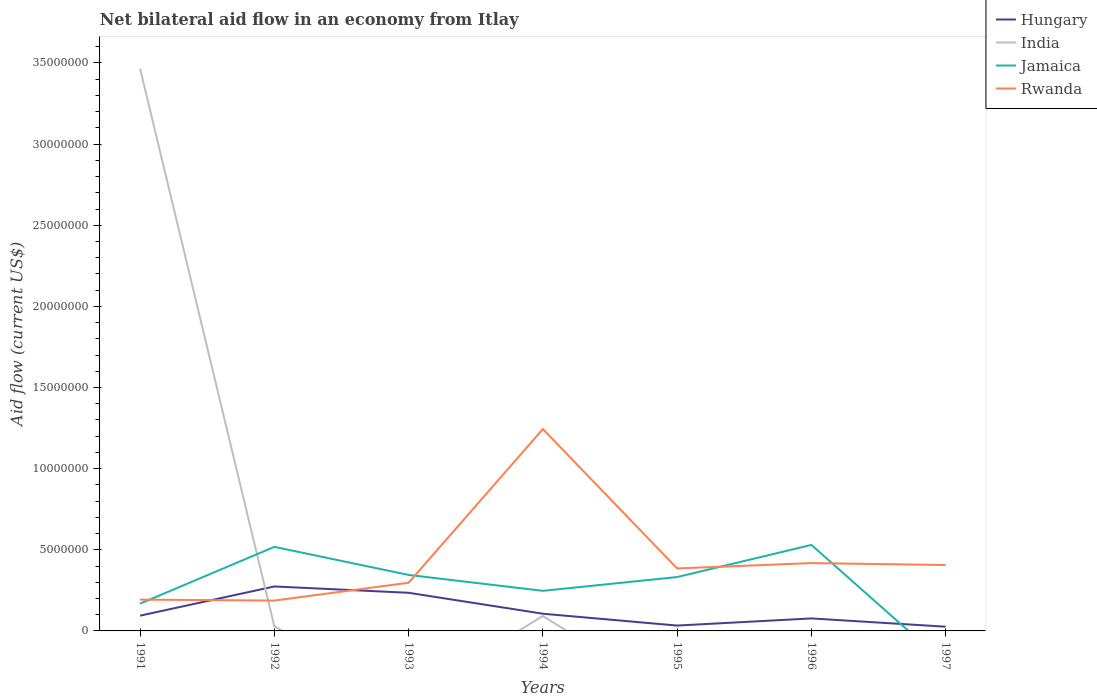How many different coloured lines are there?
Offer a terse response. 4. Is the number of lines equal to the number of legend labels?
Your response must be concise. No. Across all years, what is the maximum net bilateral aid flow in India?
Give a very brief answer. 0. What is the total net bilateral aid flow in India in the graph?
Your answer should be compact. 3.37e+07. What is the difference between the highest and the second highest net bilateral aid flow in Hungary?
Provide a succinct answer. 2.48e+06. Is the net bilateral aid flow in Jamaica strictly greater than the net bilateral aid flow in India over the years?
Give a very brief answer. No. What is the difference between two consecutive major ticks on the Y-axis?
Offer a very short reply. 5.00e+06. Are the values on the major ticks of Y-axis written in scientific E-notation?
Offer a very short reply. No. Where does the legend appear in the graph?
Give a very brief answer. Top right. What is the title of the graph?
Your response must be concise. Net bilateral aid flow in an economy from Itlay. Does "India" appear as one of the legend labels in the graph?
Your answer should be very brief. Yes. What is the Aid flow (current US$) of Hungary in 1991?
Give a very brief answer. 9.40e+05. What is the Aid flow (current US$) of India in 1991?
Give a very brief answer. 3.46e+07. What is the Aid flow (current US$) of Jamaica in 1991?
Keep it short and to the point. 1.68e+06. What is the Aid flow (current US$) in Rwanda in 1991?
Provide a short and direct response. 1.93e+06. What is the Aid flow (current US$) of Hungary in 1992?
Ensure brevity in your answer.  2.74e+06. What is the Aid flow (current US$) in Jamaica in 1992?
Ensure brevity in your answer.  5.18e+06. What is the Aid flow (current US$) of Rwanda in 1992?
Your answer should be compact. 1.87e+06. What is the Aid flow (current US$) of Hungary in 1993?
Your response must be concise. 2.35e+06. What is the Aid flow (current US$) of Jamaica in 1993?
Give a very brief answer. 3.45e+06. What is the Aid flow (current US$) in Rwanda in 1993?
Your answer should be compact. 2.97e+06. What is the Aid flow (current US$) of Hungary in 1994?
Offer a terse response. 1.06e+06. What is the Aid flow (current US$) in India in 1994?
Your answer should be very brief. 9.20e+05. What is the Aid flow (current US$) in Jamaica in 1994?
Make the answer very short. 2.47e+06. What is the Aid flow (current US$) in Rwanda in 1994?
Ensure brevity in your answer.  1.24e+07. What is the Aid flow (current US$) of Hungary in 1995?
Offer a terse response. 3.30e+05. What is the Aid flow (current US$) in India in 1995?
Provide a succinct answer. 0. What is the Aid flow (current US$) in Jamaica in 1995?
Provide a succinct answer. 3.32e+06. What is the Aid flow (current US$) in Rwanda in 1995?
Your answer should be compact. 3.85e+06. What is the Aid flow (current US$) in Hungary in 1996?
Ensure brevity in your answer.  7.70e+05. What is the Aid flow (current US$) in Jamaica in 1996?
Offer a terse response. 5.30e+06. What is the Aid flow (current US$) of Rwanda in 1996?
Ensure brevity in your answer.  4.18e+06. What is the Aid flow (current US$) in India in 1997?
Make the answer very short. 0. What is the Aid flow (current US$) in Jamaica in 1997?
Offer a terse response. 0. What is the Aid flow (current US$) of Rwanda in 1997?
Your response must be concise. 4.06e+06. Across all years, what is the maximum Aid flow (current US$) in Hungary?
Provide a succinct answer. 2.74e+06. Across all years, what is the maximum Aid flow (current US$) of India?
Make the answer very short. 3.46e+07. Across all years, what is the maximum Aid flow (current US$) of Jamaica?
Offer a terse response. 5.30e+06. Across all years, what is the maximum Aid flow (current US$) in Rwanda?
Offer a terse response. 1.24e+07. Across all years, what is the minimum Aid flow (current US$) in Hungary?
Make the answer very short. 2.60e+05. Across all years, what is the minimum Aid flow (current US$) of Rwanda?
Offer a terse response. 1.87e+06. What is the total Aid flow (current US$) in Hungary in the graph?
Your answer should be compact. 8.45e+06. What is the total Aid flow (current US$) of India in the graph?
Your response must be concise. 3.58e+07. What is the total Aid flow (current US$) of Jamaica in the graph?
Provide a short and direct response. 2.14e+07. What is the total Aid flow (current US$) of Rwanda in the graph?
Ensure brevity in your answer.  3.13e+07. What is the difference between the Aid flow (current US$) of Hungary in 1991 and that in 1992?
Provide a succinct answer. -1.80e+06. What is the difference between the Aid flow (current US$) in India in 1991 and that in 1992?
Offer a very short reply. 3.44e+07. What is the difference between the Aid flow (current US$) in Jamaica in 1991 and that in 1992?
Your answer should be compact. -3.50e+06. What is the difference between the Aid flow (current US$) of Rwanda in 1991 and that in 1992?
Ensure brevity in your answer.  6.00e+04. What is the difference between the Aid flow (current US$) of Hungary in 1991 and that in 1993?
Your response must be concise. -1.41e+06. What is the difference between the Aid flow (current US$) in Jamaica in 1991 and that in 1993?
Give a very brief answer. -1.77e+06. What is the difference between the Aid flow (current US$) of Rwanda in 1991 and that in 1993?
Give a very brief answer. -1.04e+06. What is the difference between the Aid flow (current US$) in Hungary in 1991 and that in 1994?
Give a very brief answer. -1.20e+05. What is the difference between the Aid flow (current US$) of India in 1991 and that in 1994?
Provide a short and direct response. 3.37e+07. What is the difference between the Aid flow (current US$) of Jamaica in 1991 and that in 1994?
Give a very brief answer. -7.90e+05. What is the difference between the Aid flow (current US$) of Rwanda in 1991 and that in 1994?
Your answer should be compact. -1.05e+07. What is the difference between the Aid flow (current US$) of Hungary in 1991 and that in 1995?
Your response must be concise. 6.10e+05. What is the difference between the Aid flow (current US$) in Jamaica in 1991 and that in 1995?
Provide a succinct answer. -1.64e+06. What is the difference between the Aid flow (current US$) of Rwanda in 1991 and that in 1995?
Your response must be concise. -1.92e+06. What is the difference between the Aid flow (current US$) of Hungary in 1991 and that in 1996?
Give a very brief answer. 1.70e+05. What is the difference between the Aid flow (current US$) of Jamaica in 1991 and that in 1996?
Provide a short and direct response. -3.62e+06. What is the difference between the Aid flow (current US$) in Rwanda in 1991 and that in 1996?
Ensure brevity in your answer.  -2.25e+06. What is the difference between the Aid flow (current US$) in Hungary in 1991 and that in 1997?
Keep it short and to the point. 6.80e+05. What is the difference between the Aid flow (current US$) of Rwanda in 1991 and that in 1997?
Make the answer very short. -2.13e+06. What is the difference between the Aid flow (current US$) in Jamaica in 1992 and that in 1993?
Your response must be concise. 1.73e+06. What is the difference between the Aid flow (current US$) of Rwanda in 1992 and that in 1993?
Your answer should be very brief. -1.10e+06. What is the difference between the Aid flow (current US$) in Hungary in 1992 and that in 1994?
Your answer should be very brief. 1.68e+06. What is the difference between the Aid flow (current US$) in India in 1992 and that in 1994?
Your answer should be very brief. -6.40e+05. What is the difference between the Aid flow (current US$) of Jamaica in 1992 and that in 1994?
Offer a terse response. 2.71e+06. What is the difference between the Aid flow (current US$) in Rwanda in 1992 and that in 1994?
Your answer should be very brief. -1.06e+07. What is the difference between the Aid flow (current US$) of Hungary in 1992 and that in 1995?
Provide a succinct answer. 2.41e+06. What is the difference between the Aid flow (current US$) in Jamaica in 1992 and that in 1995?
Give a very brief answer. 1.86e+06. What is the difference between the Aid flow (current US$) of Rwanda in 1992 and that in 1995?
Make the answer very short. -1.98e+06. What is the difference between the Aid flow (current US$) in Hungary in 1992 and that in 1996?
Your response must be concise. 1.97e+06. What is the difference between the Aid flow (current US$) of Rwanda in 1992 and that in 1996?
Offer a very short reply. -2.31e+06. What is the difference between the Aid flow (current US$) of Hungary in 1992 and that in 1997?
Your answer should be very brief. 2.48e+06. What is the difference between the Aid flow (current US$) in Rwanda in 1992 and that in 1997?
Your answer should be very brief. -2.19e+06. What is the difference between the Aid flow (current US$) in Hungary in 1993 and that in 1994?
Make the answer very short. 1.29e+06. What is the difference between the Aid flow (current US$) of Jamaica in 1993 and that in 1994?
Make the answer very short. 9.80e+05. What is the difference between the Aid flow (current US$) in Rwanda in 1993 and that in 1994?
Your answer should be compact. -9.47e+06. What is the difference between the Aid flow (current US$) of Hungary in 1993 and that in 1995?
Offer a terse response. 2.02e+06. What is the difference between the Aid flow (current US$) of Rwanda in 1993 and that in 1995?
Your response must be concise. -8.80e+05. What is the difference between the Aid flow (current US$) of Hungary in 1993 and that in 1996?
Ensure brevity in your answer.  1.58e+06. What is the difference between the Aid flow (current US$) in Jamaica in 1993 and that in 1996?
Offer a terse response. -1.85e+06. What is the difference between the Aid flow (current US$) of Rwanda in 1993 and that in 1996?
Provide a succinct answer. -1.21e+06. What is the difference between the Aid flow (current US$) of Hungary in 1993 and that in 1997?
Your answer should be very brief. 2.09e+06. What is the difference between the Aid flow (current US$) of Rwanda in 1993 and that in 1997?
Provide a succinct answer. -1.09e+06. What is the difference between the Aid flow (current US$) of Hungary in 1994 and that in 1995?
Offer a very short reply. 7.30e+05. What is the difference between the Aid flow (current US$) of Jamaica in 1994 and that in 1995?
Your answer should be very brief. -8.50e+05. What is the difference between the Aid flow (current US$) in Rwanda in 1994 and that in 1995?
Your answer should be very brief. 8.59e+06. What is the difference between the Aid flow (current US$) of Hungary in 1994 and that in 1996?
Your response must be concise. 2.90e+05. What is the difference between the Aid flow (current US$) of Jamaica in 1994 and that in 1996?
Keep it short and to the point. -2.83e+06. What is the difference between the Aid flow (current US$) of Rwanda in 1994 and that in 1996?
Make the answer very short. 8.26e+06. What is the difference between the Aid flow (current US$) of Hungary in 1994 and that in 1997?
Your response must be concise. 8.00e+05. What is the difference between the Aid flow (current US$) in Rwanda in 1994 and that in 1997?
Provide a short and direct response. 8.38e+06. What is the difference between the Aid flow (current US$) of Hungary in 1995 and that in 1996?
Offer a terse response. -4.40e+05. What is the difference between the Aid flow (current US$) of Jamaica in 1995 and that in 1996?
Offer a terse response. -1.98e+06. What is the difference between the Aid flow (current US$) in Rwanda in 1995 and that in 1996?
Keep it short and to the point. -3.30e+05. What is the difference between the Aid flow (current US$) in Hungary in 1995 and that in 1997?
Your response must be concise. 7.00e+04. What is the difference between the Aid flow (current US$) of Hungary in 1996 and that in 1997?
Your answer should be very brief. 5.10e+05. What is the difference between the Aid flow (current US$) of Rwanda in 1996 and that in 1997?
Give a very brief answer. 1.20e+05. What is the difference between the Aid flow (current US$) of Hungary in 1991 and the Aid flow (current US$) of India in 1992?
Offer a terse response. 6.60e+05. What is the difference between the Aid flow (current US$) in Hungary in 1991 and the Aid flow (current US$) in Jamaica in 1992?
Provide a succinct answer. -4.24e+06. What is the difference between the Aid flow (current US$) in Hungary in 1991 and the Aid flow (current US$) in Rwanda in 1992?
Offer a very short reply. -9.30e+05. What is the difference between the Aid flow (current US$) of India in 1991 and the Aid flow (current US$) of Jamaica in 1992?
Offer a terse response. 2.95e+07. What is the difference between the Aid flow (current US$) of India in 1991 and the Aid flow (current US$) of Rwanda in 1992?
Your response must be concise. 3.28e+07. What is the difference between the Aid flow (current US$) of Hungary in 1991 and the Aid flow (current US$) of Jamaica in 1993?
Offer a terse response. -2.51e+06. What is the difference between the Aid flow (current US$) of Hungary in 1991 and the Aid flow (current US$) of Rwanda in 1993?
Make the answer very short. -2.03e+06. What is the difference between the Aid flow (current US$) in India in 1991 and the Aid flow (current US$) in Jamaica in 1993?
Provide a succinct answer. 3.12e+07. What is the difference between the Aid flow (current US$) of India in 1991 and the Aid flow (current US$) of Rwanda in 1993?
Give a very brief answer. 3.17e+07. What is the difference between the Aid flow (current US$) of Jamaica in 1991 and the Aid flow (current US$) of Rwanda in 1993?
Offer a very short reply. -1.29e+06. What is the difference between the Aid flow (current US$) in Hungary in 1991 and the Aid flow (current US$) in Jamaica in 1994?
Provide a short and direct response. -1.53e+06. What is the difference between the Aid flow (current US$) of Hungary in 1991 and the Aid flow (current US$) of Rwanda in 1994?
Your answer should be very brief. -1.15e+07. What is the difference between the Aid flow (current US$) of India in 1991 and the Aid flow (current US$) of Jamaica in 1994?
Provide a succinct answer. 3.22e+07. What is the difference between the Aid flow (current US$) in India in 1991 and the Aid flow (current US$) in Rwanda in 1994?
Give a very brief answer. 2.22e+07. What is the difference between the Aid flow (current US$) in Jamaica in 1991 and the Aid flow (current US$) in Rwanda in 1994?
Make the answer very short. -1.08e+07. What is the difference between the Aid flow (current US$) of Hungary in 1991 and the Aid flow (current US$) of Jamaica in 1995?
Provide a short and direct response. -2.38e+06. What is the difference between the Aid flow (current US$) of Hungary in 1991 and the Aid flow (current US$) of Rwanda in 1995?
Your answer should be compact. -2.91e+06. What is the difference between the Aid flow (current US$) of India in 1991 and the Aid flow (current US$) of Jamaica in 1995?
Give a very brief answer. 3.13e+07. What is the difference between the Aid flow (current US$) in India in 1991 and the Aid flow (current US$) in Rwanda in 1995?
Provide a succinct answer. 3.08e+07. What is the difference between the Aid flow (current US$) of Jamaica in 1991 and the Aid flow (current US$) of Rwanda in 1995?
Provide a short and direct response. -2.17e+06. What is the difference between the Aid flow (current US$) in Hungary in 1991 and the Aid flow (current US$) in Jamaica in 1996?
Give a very brief answer. -4.36e+06. What is the difference between the Aid flow (current US$) of Hungary in 1991 and the Aid flow (current US$) of Rwanda in 1996?
Your response must be concise. -3.24e+06. What is the difference between the Aid flow (current US$) in India in 1991 and the Aid flow (current US$) in Jamaica in 1996?
Offer a very short reply. 2.94e+07. What is the difference between the Aid flow (current US$) in India in 1991 and the Aid flow (current US$) in Rwanda in 1996?
Your answer should be compact. 3.05e+07. What is the difference between the Aid flow (current US$) of Jamaica in 1991 and the Aid flow (current US$) of Rwanda in 1996?
Make the answer very short. -2.50e+06. What is the difference between the Aid flow (current US$) of Hungary in 1991 and the Aid flow (current US$) of Rwanda in 1997?
Keep it short and to the point. -3.12e+06. What is the difference between the Aid flow (current US$) of India in 1991 and the Aid flow (current US$) of Rwanda in 1997?
Provide a succinct answer. 3.06e+07. What is the difference between the Aid flow (current US$) in Jamaica in 1991 and the Aid flow (current US$) in Rwanda in 1997?
Your answer should be compact. -2.38e+06. What is the difference between the Aid flow (current US$) of Hungary in 1992 and the Aid flow (current US$) of Jamaica in 1993?
Ensure brevity in your answer.  -7.10e+05. What is the difference between the Aid flow (current US$) in India in 1992 and the Aid flow (current US$) in Jamaica in 1993?
Provide a short and direct response. -3.17e+06. What is the difference between the Aid flow (current US$) in India in 1992 and the Aid flow (current US$) in Rwanda in 1993?
Make the answer very short. -2.69e+06. What is the difference between the Aid flow (current US$) in Jamaica in 1992 and the Aid flow (current US$) in Rwanda in 1993?
Your response must be concise. 2.21e+06. What is the difference between the Aid flow (current US$) in Hungary in 1992 and the Aid flow (current US$) in India in 1994?
Provide a short and direct response. 1.82e+06. What is the difference between the Aid flow (current US$) of Hungary in 1992 and the Aid flow (current US$) of Rwanda in 1994?
Give a very brief answer. -9.70e+06. What is the difference between the Aid flow (current US$) of India in 1992 and the Aid flow (current US$) of Jamaica in 1994?
Make the answer very short. -2.19e+06. What is the difference between the Aid flow (current US$) of India in 1992 and the Aid flow (current US$) of Rwanda in 1994?
Give a very brief answer. -1.22e+07. What is the difference between the Aid flow (current US$) of Jamaica in 1992 and the Aid flow (current US$) of Rwanda in 1994?
Your answer should be very brief. -7.26e+06. What is the difference between the Aid flow (current US$) in Hungary in 1992 and the Aid flow (current US$) in Jamaica in 1995?
Keep it short and to the point. -5.80e+05. What is the difference between the Aid flow (current US$) of Hungary in 1992 and the Aid flow (current US$) of Rwanda in 1995?
Offer a very short reply. -1.11e+06. What is the difference between the Aid flow (current US$) in India in 1992 and the Aid flow (current US$) in Jamaica in 1995?
Ensure brevity in your answer.  -3.04e+06. What is the difference between the Aid flow (current US$) of India in 1992 and the Aid flow (current US$) of Rwanda in 1995?
Provide a short and direct response. -3.57e+06. What is the difference between the Aid flow (current US$) of Jamaica in 1992 and the Aid flow (current US$) of Rwanda in 1995?
Your response must be concise. 1.33e+06. What is the difference between the Aid flow (current US$) in Hungary in 1992 and the Aid flow (current US$) in Jamaica in 1996?
Give a very brief answer. -2.56e+06. What is the difference between the Aid flow (current US$) in Hungary in 1992 and the Aid flow (current US$) in Rwanda in 1996?
Offer a very short reply. -1.44e+06. What is the difference between the Aid flow (current US$) in India in 1992 and the Aid flow (current US$) in Jamaica in 1996?
Provide a short and direct response. -5.02e+06. What is the difference between the Aid flow (current US$) of India in 1992 and the Aid flow (current US$) of Rwanda in 1996?
Your response must be concise. -3.90e+06. What is the difference between the Aid flow (current US$) in Jamaica in 1992 and the Aid flow (current US$) in Rwanda in 1996?
Provide a short and direct response. 1.00e+06. What is the difference between the Aid flow (current US$) in Hungary in 1992 and the Aid flow (current US$) in Rwanda in 1997?
Offer a terse response. -1.32e+06. What is the difference between the Aid flow (current US$) of India in 1992 and the Aid flow (current US$) of Rwanda in 1997?
Offer a very short reply. -3.78e+06. What is the difference between the Aid flow (current US$) of Jamaica in 1992 and the Aid flow (current US$) of Rwanda in 1997?
Offer a terse response. 1.12e+06. What is the difference between the Aid flow (current US$) of Hungary in 1993 and the Aid flow (current US$) of India in 1994?
Your response must be concise. 1.43e+06. What is the difference between the Aid flow (current US$) of Hungary in 1993 and the Aid flow (current US$) of Rwanda in 1994?
Offer a terse response. -1.01e+07. What is the difference between the Aid flow (current US$) of Jamaica in 1993 and the Aid flow (current US$) of Rwanda in 1994?
Give a very brief answer. -8.99e+06. What is the difference between the Aid flow (current US$) of Hungary in 1993 and the Aid flow (current US$) of Jamaica in 1995?
Give a very brief answer. -9.70e+05. What is the difference between the Aid flow (current US$) of Hungary in 1993 and the Aid flow (current US$) of Rwanda in 1995?
Ensure brevity in your answer.  -1.50e+06. What is the difference between the Aid flow (current US$) of Jamaica in 1993 and the Aid flow (current US$) of Rwanda in 1995?
Provide a succinct answer. -4.00e+05. What is the difference between the Aid flow (current US$) of Hungary in 1993 and the Aid flow (current US$) of Jamaica in 1996?
Your response must be concise. -2.95e+06. What is the difference between the Aid flow (current US$) of Hungary in 1993 and the Aid flow (current US$) of Rwanda in 1996?
Give a very brief answer. -1.83e+06. What is the difference between the Aid flow (current US$) in Jamaica in 1993 and the Aid flow (current US$) in Rwanda in 1996?
Your answer should be compact. -7.30e+05. What is the difference between the Aid flow (current US$) of Hungary in 1993 and the Aid flow (current US$) of Rwanda in 1997?
Give a very brief answer. -1.71e+06. What is the difference between the Aid flow (current US$) in Jamaica in 1993 and the Aid flow (current US$) in Rwanda in 1997?
Your response must be concise. -6.10e+05. What is the difference between the Aid flow (current US$) of Hungary in 1994 and the Aid flow (current US$) of Jamaica in 1995?
Your response must be concise. -2.26e+06. What is the difference between the Aid flow (current US$) of Hungary in 1994 and the Aid flow (current US$) of Rwanda in 1995?
Your response must be concise. -2.79e+06. What is the difference between the Aid flow (current US$) in India in 1994 and the Aid flow (current US$) in Jamaica in 1995?
Give a very brief answer. -2.40e+06. What is the difference between the Aid flow (current US$) of India in 1994 and the Aid flow (current US$) of Rwanda in 1995?
Make the answer very short. -2.93e+06. What is the difference between the Aid flow (current US$) of Jamaica in 1994 and the Aid flow (current US$) of Rwanda in 1995?
Offer a terse response. -1.38e+06. What is the difference between the Aid flow (current US$) of Hungary in 1994 and the Aid flow (current US$) of Jamaica in 1996?
Offer a very short reply. -4.24e+06. What is the difference between the Aid flow (current US$) in Hungary in 1994 and the Aid flow (current US$) in Rwanda in 1996?
Give a very brief answer. -3.12e+06. What is the difference between the Aid flow (current US$) in India in 1994 and the Aid flow (current US$) in Jamaica in 1996?
Provide a succinct answer. -4.38e+06. What is the difference between the Aid flow (current US$) in India in 1994 and the Aid flow (current US$) in Rwanda in 1996?
Your response must be concise. -3.26e+06. What is the difference between the Aid flow (current US$) in Jamaica in 1994 and the Aid flow (current US$) in Rwanda in 1996?
Provide a short and direct response. -1.71e+06. What is the difference between the Aid flow (current US$) of Hungary in 1994 and the Aid flow (current US$) of Rwanda in 1997?
Give a very brief answer. -3.00e+06. What is the difference between the Aid flow (current US$) of India in 1994 and the Aid flow (current US$) of Rwanda in 1997?
Your answer should be very brief. -3.14e+06. What is the difference between the Aid flow (current US$) of Jamaica in 1994 and the Aid flow (current US$) of Rwanda in 1997?
Ensure brevity in your answer.  -1.59e+06. What is the difference between the Aid flow (current US$) of Hungary in 1995 and the Aid flow (current US$) of Jamaica in 1996?
Offer a very short reply. -4.97e+06. What is the difference between the Aid flow (current US$) in Hungary in 1995 and the Aid flow (current US$) in Rwanda in 1996?
Make the answer very short. -3.85e+06. What is the difference between the Aid flow (current US$) of Jamaica in 1995 and the Aid flow (current US$) of Rwanda in 1996?
Provide a succinct answer. -8.60e+05. What is the difference between the Aid flow (current US$) of Hungary in 1995 and the Aid flow (current US$) of Rwanda in 1997?
Offer a terse response. -3.73e+06. What is the difference between the Aid flow (current US$) in Jamaica in 1995 and the Aid flow (current US$) in Rwanda in 1997?
Give a very brief answer. -7.40e+05. What is the difference between the Aid flow (current US$) in Hungary in 1996 and the Aid flow (current US$) in Rwanda in 1997?
Make the answer very short. -3.29e+06. What is the difference between the Aid flow (current US$) in Jamaica in 1996 and the Aid flow (current US$) in Rwanda in 1997?
Give a very brief answer. 1.24e+06. What is the average Aid flow (current US$) of Hungary per year?
Ensure brevity in your answer.  1.21e+06. What is the average Aid flow (current US$) in India per year?
Provide a succinct answer. 5.12e+06. What is the average Aid flow (current US$) in Jamaica per year?
Your response must be concise. 3.06e+06. What is the average Aid flow (current US$) of Rwanda per year?
Your answer should be compact. 4.47e+06. In the year 1991, what is the difference between the Aid flow (current US$) of Hungary and Aid flow (current US$) of India?
Ensure brevity in your answer.  -3.37e+07. In the year 1991, what is the difference between the Aid flow (current US$) of Hungary and Aid flow (current US$) of Jamaica?
Ensure brevity in your answer.  -7.40e+05. In the year 1991, what is the difference between the Aid flow (current US$) of Hungary and Aid flow (current US$) of Rwanda?
Provide a short and direct response. -9.90e+05. In the year 1991, what is the difference between the Aid flow (current US$) in India and Aid flow (current US$) in Jamaica?
Provide a short and direct response. 3.30e+07. In the year 1991, what is the difference between the Aid flow (current US$) in India and Aid flow (current US$) in Rwanda?
Provide a short and direct response. 3.27e+07. In the year 1992, what is the difference between the Aid flow (current US$) in Hungary and Aid flow (current US$) in India?
Your response must be concise. 2.46e+06. In the year 1992, what is the difference between the Aid flow (current US$) in Hungary and Aid flow (current US$) in Jamaica?
Your response must be concise. -2.44e+06. In the year 1992, what is the difference between the Aid flow (current US$) in Hungary and Aid flow (current US$) in Rwanda?
Provide a succinct answer. 8.70e+05. In the year 1992, what is the difference between the Aid flow (current US$) of India and Aid flow (current US$) of Jamaica?
Your response must be concise. -4.90e+06. In the year 1992, what is the difference between the Aid flow (current US$) of India and Aid flow (current US$) of Rwanda?
Your response must be concise. -1.59e+06. In the year 1992, what is the difference between the Aid flow (current US$) in Jamaica and Aid flow (current US$) in Rwanda?
Offer a terse response. 3.31e+06. In the year 1993, what is the difference between the Aid flow (current US$) in Hungary and Aid flow (current US$) in Jamaica?
Offer a terse response. -1.10e+06. In the year 1993, what is the difference between the Aid flow (current US$) of Hungary and Aid flow (current US$) of Rwanda?
Give a very brief answer. -6.20e+05. In the year 1994, what is the difference between the Aid flow (current US$) in Hungary and Aid flow (current US$) in Jamaica?
Provide a short and direct response. -1.41e+06. In the year 1994, what is the difference between the Aid flow (current US$) in Hungary and Aid flow (current US$) in Rwanda?
Your answer should be very brief. -1.14e+07. In the year 1994, what is the difference between the Aid flow (current US$) of India and Aid flow (current US$) of Jamaica?
Your answer should be very brief. -1.55e+06. In the year 1994, what is the difference between the Aid flow (current US$) of India and Aid flow (current US$) of Rwanda?
Offer a terse response. -1.15e+07. In the year 1994, what is the difference between the Aid flow (current US$) in Jamaica and Aid flow (current US$) in Rwanda?
Keep it short and to the point. -9.97e+06. In the year 1995, what is the difference between the Aid flow (current US$) in Hungary and Aid flow (current US$) in Jamaica?
Give a very brief answer. -2.99e+06. In the year 1995, what is the difference between the Aid flow (current US$) in Hungary and Aid flow (current US$) in Rwanda?
Give a very brief answer. -3.52e+06. In the year 1995, what is the difference between the Aid flow (current US$) of Jamaica and Aid flow (current US$) of Rwanda?
Give a very brief answer. -5.30e+05. In the year 1996, what is the difference between the Aid flow (current US$) in Hungary and Aid flow (current US$) in Jamaica?
Make the answer very short. -4.53e+06. In the year 1996, what is the difference between the Aid flow (current US$) in Hungary and Aid flow (current US$) in Rwanda?
Your answer should be compact. -3.41e+06. In the year 1996, what is the difference between the Aid flow (current US$) of Jamaica and Aid flow (current US$) of Rwanda?
Your answer should be very brief. 1.12e+06. In the year 1997, what is the difference between the Aid flow (current US$) of Hungary and Aid flow (current US$) of Rwanda?
Provide a short and direct response. -3.80e+06. What is the ratio of the Aid flow (current US$) of Hungary in 1991 to that in 1992?
Offer a very short reply. 0.34. What is the ratio of the Aid flow (current US$) of India in 1991 to that in 1992?
Keep it short and to the point. 123.75. What is the ratio of the Aid flow (current US$) of Jamaica in 1991 to that in 1992?
Give a very brief answer. 0.32. What is the ratio of the Aid flow (current US$) of Rwanda in 1991 to that in 1992?
Your answer should be very brief. 1.03. What is the ratio of the Aid flow (current US$) in Jamaica in 1991 to that in 1993?
Ensure brevity in your answer.  0.49. What is the ratio of the Aid flow (current US$) in Rwanda in 1991 to that in 1993?
Your response must be concise. 0.65. What is the ratio of the Aid flow (current US$) in Hungary in 1991 to that in 1994?
Ensure brevity in your answer.  0.89. What is the ratio of the Aid flow (current US$) of India in 1991 to that in 1994?
Keep it short and to the point. 37.66. What is the ratio of the Aid flow (current US$) of Jamaica in 1991 to that in 1994?
Offer a terse response. 0.68. What is the ratio of the Aid flow (current US$) in Rwanda in 1991 to that in 1994?
Your answer should be compact. 0.16. What is the ratio of the Aid flow (current US$) in Hungary in 1991 to that in 1995?
Ensure brevity in your answer.  2.85. What is the ratio of the Aid flow (current US$) in Jamaica in 1991 to that in 1995?
Your answer should be compact. 0.51. What is the ratio of the Aid flow (current US$) in Rwanda in 1991 to that in 1995?
Provide a succinct answer. 0.5. What is the ratio of the Aid flow (current US$) in Hungary in 1991 to that in 1996?
Make the answer very short. 1.22. What is the ratio of the Aid flow (current US$) in Jamaica in 1991 to that in 1996?
Your answer should be very brief. 0.32. What is the ratio of the Aid flow (current US$) in Rwanda in 1991 to that in 1996?
Keep it short and to the point. 0.46. What is the ratio of the Aid flow (current US$) of Hungary in 1991 to that in 1997?
Your answer should be very brief. 3.62. What is the ratio of the Aid flow (current US$) in Rwanda in 1991 to that in 1997?
Your response must be concise. 0.48. What is the ratio of the Aid flow (current US$) in Hungary in 1992 to that in 1993?
Provide a short and direct response. 1.17. What is the ratio of the Aid flow (current US$) in Jamaica in 1992 to that in 1993?
Your answer should be very brief. 1.5. What is the ratio of the Aid flow (current US$) of Rwanda in 1992 to that in 1993?
Your answer should be very brief. 0.63. What is the ratio of the Aid flow (current US$) of Hungary in 1992 to that in 1994?
Provide a succinct answer. 2.58. What is the ratio of the Aid flow (current US$) in India in 1992 to that in 1994?
Give a very brief answer. 0.3. What is the ratio of the Aid flow (current US$) in Jamaica in 1992 to that in 1994?
Your response must be concise. 2.1. What is the ratio of the Aid flow (current US$) of Rwanda in 1992 to that in 1994?
Provide a succinct answer. 0.15. What is the ratio of the Aid flow (current US$) of Hungary in 1992 to that in 1995?
Offer a terse response. 8.3. What is the ratio of the Aid flow (current US$) of Jamaica in 1992 to that in 1995?
Keep it short and to the point. 1.56. What is the ratio of the Aid flow (current US$) in Rwanda in 1992 to that in 1995?
Give a very brief answer. 0.49. What is the ratio of the Aid flow (current US$) in Hungary in 1992 to that in 1996?
Provide a succinct answer. 3.56. What is the ratio of the Aid flow (current US$) in Jamaica in 1992 to that in 1996?
Ensure brevity in your answer.  0.98. What is the ratio of the Aid flow (current US$) of Rwanda in 1992 to that in 1996?
Ensure brevity in your answer.  0.45. What is the ratio of the Aid flow (current US$) of Hungary in 1992 to that in 1997?
Your answer should be very brief. 10.54. What is the ratio of the Aid flow (current US$) of Rwanda in 1992 to that in 1997?
Provide a short and direct response. 0.46. What is the ratio of the Aid flow (current US$) in Hungary in 1993 to that in 1994?
Offer a terse response. 2.22. What is the ratio of the Aid flow (current US$) of Jamaica in 1993 to that in 1994?
Provide a short and direct response. 1.4. What is the ratio of the Aid flow (current US$) in Rwanda in 1993 to that in 1994?
Your response must be concise. 0.24. What is the ratio of the Aid flow (current US$) in Hungary in 1993 to that in 1995?
Your response must be concise. 7.12. What is the ratio of the Aid flow (current US$) of Jamaica in 1993 to that in 1995?
Your response must be concise. 1.04. What is the ratio of the Aid flow (current US$) of Rwanda in 1993 to that in 1995?
Your answer should be very brief. 0.77. What is the ratio of the Aid flow (current US$) of Hungary in 1993 to that in 1996?
Keep it short and to the point. 3.05. What is the ratio of the Aid flow (current US$) of Jamaica in 1993 to that in 1996?
Make the answer very short. 0.65. What is the ratio of the Aid flow (current US$) in Rwanda in 1993 to that in 1996?
Make the answer very short. 0.71. What is the ratio of the Aid flow (current US$) in Hungary in 1993 to that in 1997?
Offer a terse response. 9.04. What is the ratio of the Aid flow (current US$) in Rwanda in 1993 to that in 1997?
Your answer should be very brief. 0.73. What is the ratio of the Aid flow (current US$) in Hungary in 1994 to that in 1995?
Offer a terse response. 3.21. What is the ratio of the Aid flow (current US$) of Jamaica in 1994 to that in 1995?
Make the answer very short. 0.74. What is the ratio of the Aid flow (current US$) of Rwanda in 1994 to that in 1995?
Ensure brevity in your answer.  3.23. What is the ratio of the Aid flow (current US$) of Hungary in 1994 to that in 1996?
Your answer should be compact. 1.38. What is the ratio of the Aid flow (current US$) in Jamaica in 1994 to that in 1996?
Your answer should be very brief. 0.47. What is the ratio of the Aid flow (current US$) of Rwanda in 1994 to that in 1996?
Your answer should be very brief. 2.98. What is the ratio of the Aid flow (current US$) in Hungary in 1994 to that in 1997?
Offer a terse response. 4.08. What is the ratio of the Aid flow (current US$) in Rwanda in 1994 to that in 1997?
Offer a very short reply. 3.06. What is the ratio of the Aid flow (current US$) of Hungary in 1995 to that in 1996?
Your answer should be compact. 0.43. What is the ratio of the Aid flow (current US$) of Jamaica in 1995 to that in 1996?
Provide a succinct answer. 0.63. What is the ratio of the Aid flow (current US$) of Rwanda in 1995 to that in 1996?
Keep it short and to the point. 0.92. What is the ratio of the Aid flow (current US$) of Hungary in 1995 to that in 1997?
Make the answer very short. 1.27. What is the ratio of the Aid flow (current US$) in Rwanda in 1995 to that in 1997?
Give a very brief answer. 0.95. What is the ratio of the Aid flow (current US$) in Hungary in 1996 to that in 1997?
Give a very brief answer. 2.96. What is the ratio of the Aid flow (current US$) of Rwanda in 1996 to that in 1997?
Your answer should be very brief. 1.03. What is the difference between the highest and the second highest Aid flow (current US$) of India?
Provide a succinct answer. 3.37e+07. What is the difference between the highest and the second highest Aid flow (current US$) in Jamaica?
Offer a terse response. 1.20e+05. What is the difference between the highest and the second highest Aid flow (current US$) in Rwanda?
Keep it short and to the point. 8.26e+06. What is the difference between the highest and the lowest Aid flow (current US$) in Hungary?
Your answer should be very brief. 2.48e+06. What is the difference between the highest and the lowest Aid flow (current US$) in India?
Give a very brief answer. 3.46e+07. What is the difference between the highest and the lowest Aid flow (current US$) of Jamaica?
Your response must be concise. 5.30e+06. What is the difference between the highest and the lowest Aid flow (current US$) of Rwanda?
Make the answer very short. 1.06e+07. 